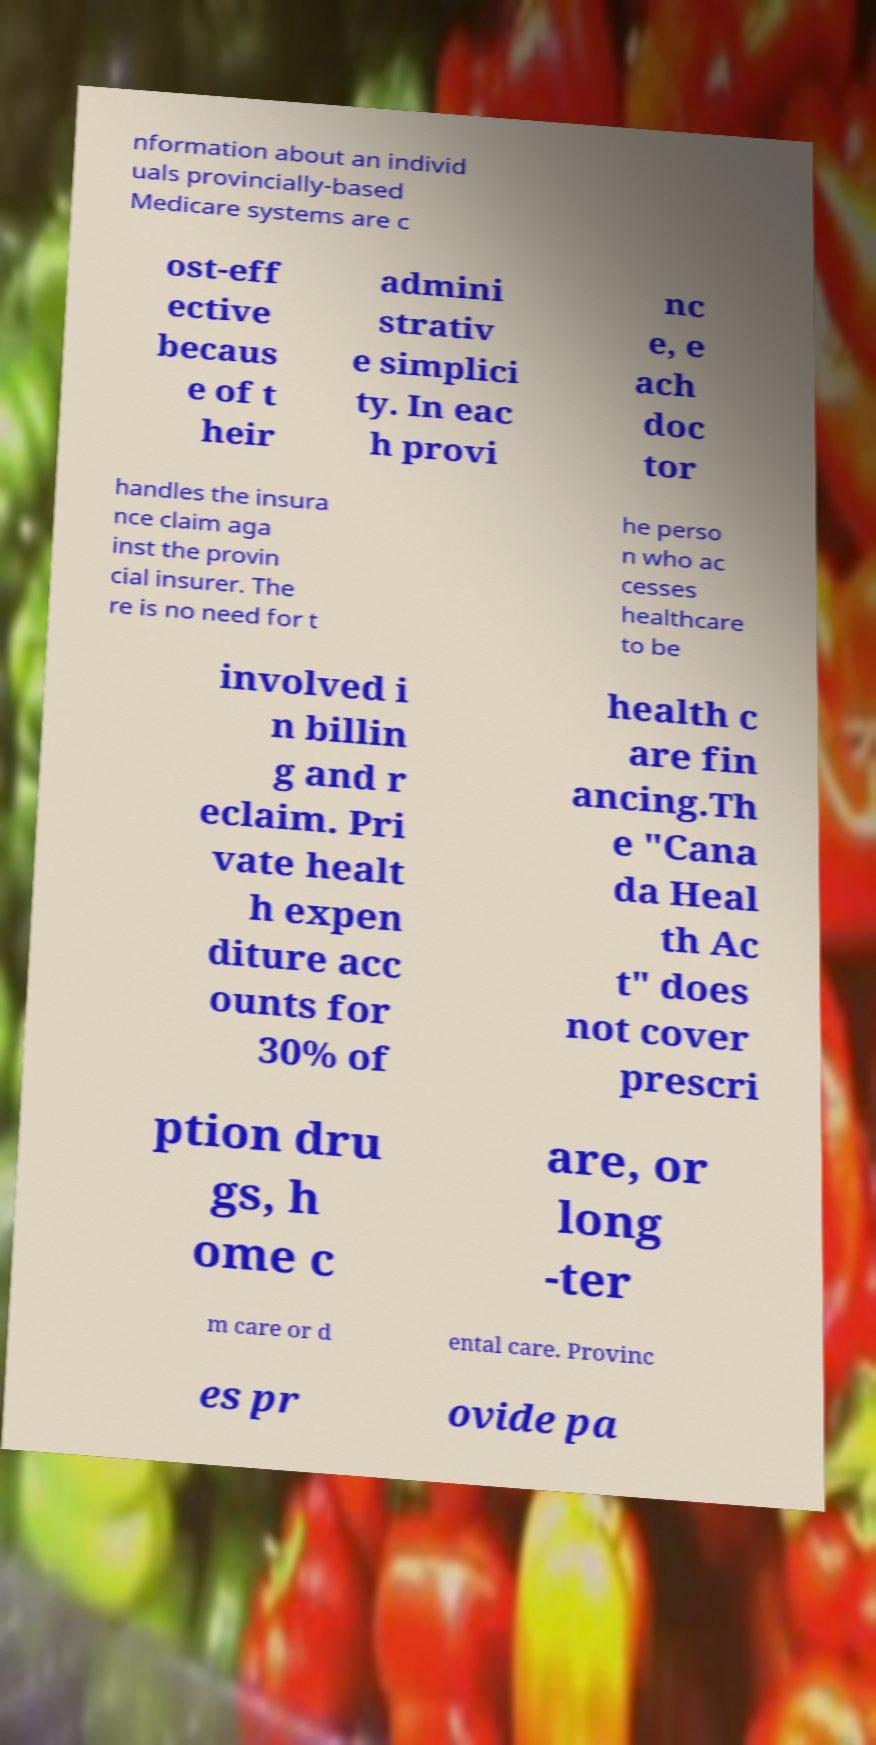Can you read and provide the text displayed in the image?This photo seems to have some interesting text. Can you extract and type it out for me? nformation about an individ uals provincially-based Medicare systems are c ost-eff ective becaus e of t heir admini strativ e simplici ty. In eac h provi nc e, e ach doc tor handles the insura nce claim aga inst the provin cial insurer. The re is no need for t he perso n who ac cesses healthcare to be involved i n billin g and r eclaim. Pri vate healt h expen diture acc ounts for 30% of health c are fin ancing.Th e "Cana da Heal th Ac t" does not cover prescri ption dru gs, h ome c are, or long -ter m care or d ental care. Provinc es pr ovide pa 